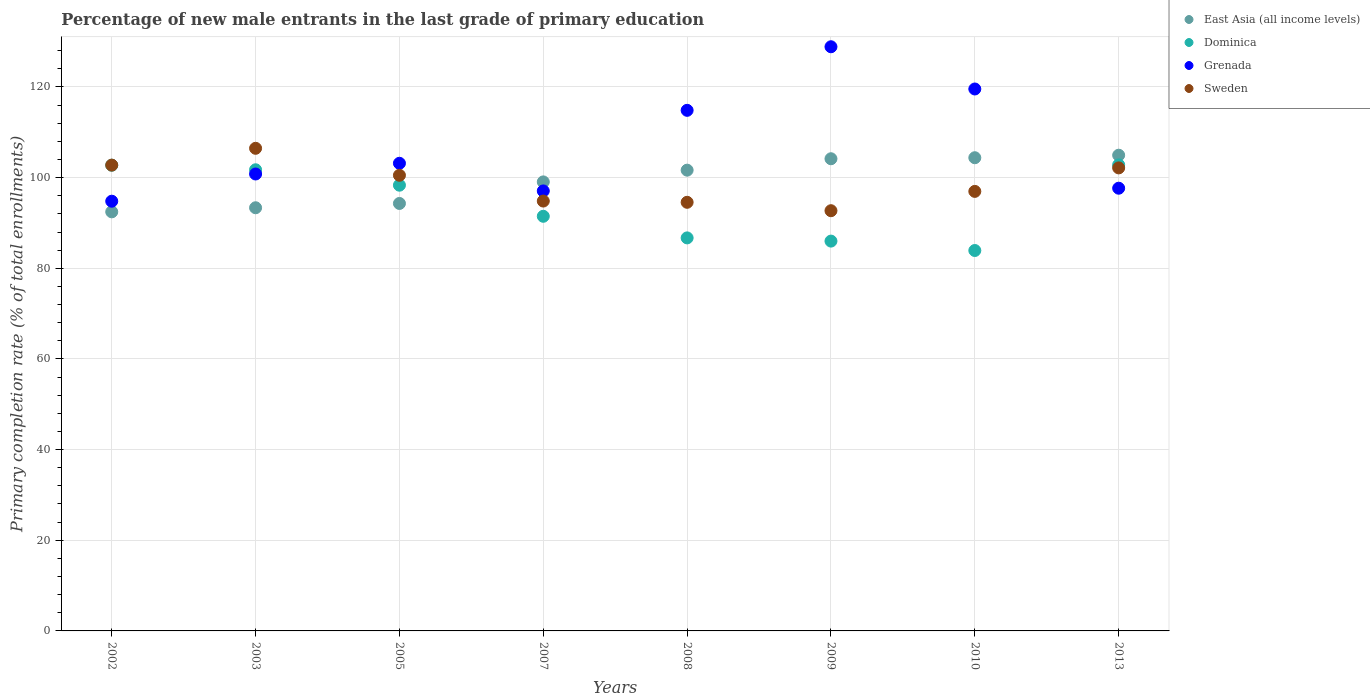How many different coloured dotlines are there?
Give a very brief answer. 4. Is the number of dotlines equal to the number of legend labels?
Ensure brevity in your answer.  Yes. What is the percentage of new male entrants in East Asia (all income levels) in 2007?
Give a very brief answer. 99.06. Across all years, what is the maximum percentage of new male entrants in Dominica?
Your answer should be very brief. 102.82. Across all years, what is the minimum percentage of new male entrants in Grenada?
Ensure brevity in your answer.  94.8. In which year was the percentage of new male entrants in East Asia (all income levels) minimum?
Keep it short and to the point. 2002. What is the total percentage of new male entrants in East Asia (all income levels) in the graph?
Keep it short and to the point. 794.31. What is the difference between the percentage of new male entrants in Sweden in 2002 and that in 2003?
Give a very brief answer. -3.71. What is the difference between the percentage of new male entrants in East Asia (all income levels) in 2002 and the percentage of new male entrants in Sweden in 2009?
Your response must be concise. -0.25. What is the average percentage of new male entrants in East Asia (all income levels) per year?
Keep it short and to the point. 99.29. In the year 2005, what is the difference between the percentage of new male entrants in Sweden and percentage of new male entrants in Grenada?
Keep it short and to the point. -2.65. What is the ratio of the percentage of new male entrants in Sweden in 2002 to that in 2010?
Provide a succinct answer. 1.06. Is the percentage of new male entrants in Grenada in 2003 less than that in 2013?
Ensure brevity in your answer.  No. Is the difference between the percentage of new male entrants in Sweden in 2009 and 2010 greater than the difference between the percentage of new male entrants in Grenada in 2009 and 2010?
Your answer should be compact. No. What is the difference between the highest and the second highest percentage of new male entrants in Sweden?
Offer a terse response. 3.71. What is the difference between the highest and the lowest percentage of new male entrants in Dominica?
Give a very brief answer. 18.9. In how many years, is the percentage of new male entrants in Grenada greater than the average percentage of new male entrants in Grenada taken over all years?
Provide a succinct answer. 3. Is the sum of the percentage of new male entrants in Grenada in 2002 and 2003 greater than the maximum percentage of new male entrants in East Asia (all income levels) across all years?
Keep it short and to the point. Yes. Is it the case that in every year, the sum of the percentage of new male entrants in Dominica and percentage of new male entrants in Grenada  is greater than the percentage of new male entrants in East Asia (all income levels)?
Your response must be concise. Yes. Does the percentage of new male entrants in Grenada monotonically increase over the years?
Your response must be concise. No. Is the percentage of new male entrants in Dominica strictly greater than the percentage of new male entrants in East Asia (all income levels) over the years?
Give a very brief answer. No. Is the percentage of new male entrants in Dominica strictly less than the percentage of new male entrants in Grenada over the years?
Ensure brevity in your answer.  No. How many years are there in the graph?
Ensure brevity in your answer.  8. What is the difference between two consecutive major ticks on the Y-axis?
Provide a succinct answer. 20. Are the values on the major ticks of Y-axis written in scientific E-notation?
Offer a terse response. No. Does the graph contain any zero values?
Give a very brief answer. No. Where does the legend appear in the graph?
Offer a very short reply. Top right. How are the legend labels stacked?
Give a very brief answer. Vertical. What is the title of the graph?
Your response must be concise. Percentage of new male entrants in the last grade of primary education. What is the label or title of the Y-axis?
Offer a very short reply. Primary completion rate (% of total enrollments). What is the Primary completion rate (% of total enrollments) in East Asia (all income levels) in 2002?
Provide a short and direct response. 92.45. What is the Primary completion rate (% of total enrollments) in Dominica in 2002?
Give a very brief answer. 102.74. What is the Primary completion rate (% of total enrollments) in Grenada in 2002?
Make the answer very short. 94.8. What is the Primary completion rate (% of total enrollments) in Sweden in 2002?
Offer a terse response. 102.76. What is the Primary completion rate (% of total enrollments) in East Asia (all income levels) in 2003?
Your answer should be compact. 93.35. What is the Primary completion rate (% of total enrollments) in Dominica in 2003?
Make the answer very short. 101.73. What is the Primary completion rate (% of total enrollments) in Grenada in 2003?
Provide a succinct answer. 100.8. What is the Primary completion rate (% of total enrollments) of Sweden in 2003?
Keep it short and to the point. 106.47. What is the Primary completion rate (% of total enrollments) in East Asia (all income levels) in 2005?
Offer a terse response. 94.3. What is the Primary completion rate (% of total enrollments) in Dominica in 2005?
Your answer should be very brief. 98.33. What is the Primary completion rate (% of total enrollments) of Grenada in 2005?
Give a very brief answer. 103.17. What is the Primary completion rate (% of total enrollments) in Sweden in 2005?
Keep it short and to the point. 100.52. What is the Primary completion rate (% of total enrollments) of East Asia (all income levels) in 2007?
Your answer should be very brief. 99.06. What is the Primary completion rate (% of total enrollments) in Dominica in 2007?
Provide a succinct answer. 91.47. What is the Primary completion rate (% of total enrollments) of Grenada in 2007?
Keep it short and to the point. 97.07. What is the Primary completion rate (% of total enrollments) of Sweden in 2007?
Keep it short and to the point. 94.83. What is the Primary completion rate (% of total enrollments) in East Asia (all income levels) in 2008?
Keep it short and to the point. 101.65. What is the Primary completion rate (% of total enrollments) in Dominica in 2008?
Your answer should be compact. 86.71. What is the Primary completion rate (% of total enrollments) of Grenada in 2008?
Provide a short and direct response. 114.85. What is the Primary completion rate (% of total enrollments) of Sweden in 2008?
Give a very brief answer. 94.56. What is the Primary completion rate (% of total enrollments) of East Asia (all income levels) in 2009?
Provide a short and direct response. 104.16. What is the Primary completion rate (% of total enrollments) of Dominica in 2009?
Your answer should be very brief. 86. What is the Primary completion rate (% of total enrollments) in Grenada in 2009?
Make the answer very short. 128.87. What is the Primary completion rate (% of total enrollments) in Sweden in 2009?
Your response must be concise. 92.7. What is the Primary completion rate (% of total enrollments) in East Asia (all income levels) in 2010?
Offer a very short reply. 104.39. What is the Primary completion rate (% of total enrollments) of Dominica in 2010?
Provide a short and direct response. 83.92. What is the Primary completion rate (% of total enrollments) in Grenada in 2010?
Offer a terse response. 119.55. What is the Primary completion rate (% of total enrollments) of Sweden in 2010?
Provide a succinct answer. 96.96. What is the Primary completion rate (% of total enrollments) in East Asia (all income levels) in 2013?
Offer a very short reply. 104.95. What is the Primary completion rate (% of total enrollments) in Dominica in 2013?
Offer a terse response. 102.82. What is the Primary completion rate (% of total enrollments) of Grenada in 2013?
Keep it short and to the point. 97.66. What is the Primary completion rate (% of total enrollments) in Sweden in 2013?
Make the answer very short. 102.15. Across all years, what is the maximum Primary completion rate (% of total enrollments) of East Asia (all income levels)?
Give a very brief answer. 104.95. Across all years, what is the maximum Primary completion rate (% of total enrollments) of Dominica?
Keep it short and to the point. 102.82. Across all years, what is the maximum Primary completion rate (% of total enrollments) of Grenada?
Your answer should be very brief. 128.87. Across all years, what is the maximum Primary completion rate (% of total enrollments) in Sweden?
Your answer should be compact. 106.47. Across all years, what is the minimum Primary completion rate (% of total enrollments) in East Asia (all income levels)?
Offer a very short reply. 92.45. Across all years, what is the minimum Primary completion rate (% of total enrollments) of Dominica?
Give a very brief answer. 83.92. Across all years, what is the minimum Primary completion rate (% of total enrollments) of Grenada?
Your answer should be compact. 94.8. Across all years, what is the minimum Primary completion rate (% of total enrollments) of Sweden?
Your answer should be compact. 92.7. What is the total Primary completion rate (% of total enrollments) in East Asia (all income levels) in the graph?
Make the answer very short. 794.31. What is the total Primary completion rate (% of total enrollments) in Dominica in the graph?
Provide a short and direct response. 753.72. What is the total Primary completion rate (% of total enrollments) in Grenada in the graph?
Ensure brevity in your answer.  856.77. What is the total Primary completion rate (% of total enrollments) of Sweden in the graph?
Offer a terse response. 790.94. What is the difference between the Primary completion rate (% of total enrollments) of East Asia (all income levels) in 2002 and that in 2003?
Your response must be concise. -0.9. What is the difference between the Primary completion rate (% of total enrollments) of Dominica in 2002 and that in 2003?
Your answer should be very brief. 1.01. What is the difference between the Primary completion rate (% of total enrollments) of Grenada in 2002 and that in 2003?
Make the answer very short. -6. What is the difference between the Primary completion rate (% of total enrollments) of Sweden in 2002 and that in 2003?
Offer a very short reply. -3.71. What is the difference between the Primary completion rate (% of total enrollments) of East Asia (all income levels) in 2002 and that in 2005?
Ensure brevity in your answer.  -1.85. What is the difference between the Primary completion rate (% of total enrollments) of Dominica in 2002 and that in 2005?
Offer a very short reply. 4.41. What is the difference between the Primary completion rate (% of total enrollments) in Grenada in 2002 and that in 2005?
Give a very brief answer. -8.37. What is the difference between the Primary completion rate (% of total enrollments) in Sweden in 2002 and that in 2005?
Offer a terse response. 2.24. What is the difference between the Primary completion rate (% of total enrollments) in East Asia (all income levels) in 2002 and that in 2007?
Ensure brevity in your answer.  -6.6. What is the difference between the Primary completion rate (% of total enrollments) of Dominica in 2002 and that in 2007?
Your answer should be very brief. 11.27. What is the difference between the Primary completion rate (% of total enrollments) in Grenada in 2002 and that in 2007?
Make the answer very short. -2.27. What is the difference between the Primary completion rate (% of total enrollments) of Sweden in 2002 and that in 2007?
Provide a short and direct response. 7.93. What is the difference between the Primary completion rate (% of total enrollments) in East Asia (all income levels) in 2002 and that in 2008?
Offer a very short reply. -9.19. What is the difference between the Primary completion rate (% of total enrollments) of Dominica in 2002 and that in 2008?
Offer a very short reply. 16.03. What is the difference between the Primary completion rate (% of total enrollments) in Grenada in 2002 and that in 2008?
Your answer should be very brief. -20.05. What is the difference between the Primary completion rate (% of total enrollments) in Sweden in 2002 and that in 2008?
Offer a terse response. 8.2. What is the difference between the Primary completion rate (% of total enrollments) in East Asia (all income levels) in 2002 and that in 2009?
Keep it short and to the point. -11.71. What is the difference between the Primary completion rate (% of total enrollments) of Dominica in 2002 and that in 2009?
Make the answer very short. 16.74. What is the difference between the Primary completion rate (% of total enrollments) of Grenada in 2002 and that in 2009?
Ensure brevity in your answer.  -34.07. What is the difference between the Primary completion rate (% of total enrollments) of Sweden in 2002 and that in 2009?
Make the answer very short. 10.06. What is the difference between the Primary completion rate (% of total enrollments) of East Asia (all income levels) in 2002 and that in 2010?
Give a very brief answer. -11.94. What is the difference between the Primary completion rate (% of total enrollments) in Dominica in 2002 and that in 2010?
Provide a succinct answer. 18.82. What is the difference between the Primary completion rate (% of total enrollments) in Grenada in 2002 and that in 2010?
Provide a short and direct response. -24.76. What is the difference between the Primary completion rate (% of total enrollments) in Sweden in 2002 and that in 2010?
Your answer should be very brief. 5.8. What is the difference between the Primary completion rate (% of total enrollments) of East Asia (all income levels) in 2002 and that in 2013?
Give a very brief answer. -12.49. What is the difference between the Primary completion rate (% of total enrollments) of Dominica in 2002 and that in 2013?
Give a very brief answer. -0.08. What is the difference between the Primary completion rate (% of total enrollments) of Grenada in 2002 and that in 2013?
Your answer should be compact. -2.87. What is the difference between the Primary completion rate (% of total enrollments) in Sweden in 2002 and that in 2013?
Your response must be concise. 0.61. What is the difference between the Primary completion rate (% of total enrollments) of East Asia (all income levels) in 2003 and that in 2005?
Your answer should be very brief. -0.95. What is the difference between the Primary completion rate (% of total enrollments) of Dominica in 2003 and that in 2005?
Your response must be concise. 3.4. What is the difference between the Primary completion rate (% of total enrollments) of Grenada in 2003 and that in 2005?
Offer a very short reply. -2.37. What is the difference between the Primary completion rate (% of total enrollments) in Sweden in 2003 and that in 2005?
Give a very brief answer. 5.95. What is the difference between the Primary completion rate (% of total enrollments) of East Asia (all income levels) in 2003 and that in 2007?
Offer a very short reply. -5.71. What is the difference between the Primary completion rate (% of total enrollments) in Dominica in 2003 and that in 2007?
Ensure brevity in your answer.  10.26. What is the difference between the Primary completion rate (% of total enrollments) of Grenada in 2003 and that in 2007?
Keep it short and to the point. 3.73. What is the difference between the Primary completion rate (% of total enrollments) in Sweden in 2003 and that in 2007?
Make the answer very short. 11.64. What is the difference between the Primary completion rate (% of total enrollments) of East Asia (all income levels) in 2003 and that in 2008?
Give a very brief answer. -8.29. What is the difference between the Primary completion rate (% of total enrollments) of Dominica in 2003 and that in 2008?
Your response must be concise. 15.03. What is the difference between the Primary completion rate (% of total enrollments) of Grenada in 2003 and that in 2008?
Provide a succinct answer. -14.05. What is the difference between the Primary completion rate (% of total enrollments) in Sweden in 2003 and that in 2008?
Provide a succinct answer. 11.91. What is the difference between the Primary completion rate (% of total enrollments) in East Asia (all income levels) in 2003 and that in 2009?
Provide a succinct answer. -10.81. What is the difference between the Primary completion rate (% of total enrollments) in Dominica in 2003 and that in 2009?
Offer a very short reply. 15.74. What is the difference between the Primary completion rate (% of total enrollments) of Grenada in 2003 and that in 2009?
Provide a short and direct response. -28.07. What is the difference between the Primary completion rate (% of total enrollments) of Sweden in 2003 and that in 2009?
Offer a very short reply. 13.77. What is the difference between the Primary completion rate (% of total enrollments) of East Asia (all income levels) in 2003 and that in 2010?
Provide a short and direct response. -11.04. What is the difference between the Primary completion rate (% of total enrollments) in Dominica in 2003 and that in 2010?
Offer a very short reply. 17.81. What is the difference between the Primary completion rate (% of total enrollments) of Grenada in 2003 and that in 2010?
Your answer should be very brief. -18.75. What is the difference between the Primary completion rate (% of total enrollments) in Sweden in 2003 and that in 2010?
Provide a short and direct response. 9.51. What is the difference between the Primary completion rate (% of total enrollments) of East Asia (all income levels) in 2003 and that in 2013?
Keep it short and to the point. -11.59. What is the difference between the Primary completion rate (% of total enrollments) of Dominica in 2003 and that in 2013?
Your answer should be compact. -1.09. What is the difference between the Primary completion rate (% of total enrollments) in Grenada in 2003 and that in 2013?
Your answer should be compact. 3.14. What is the difference between the Primary completion rate (% of total enrollments) of Sweden in 2003 and that in 2013?
Provide a short and direct response. 4.32. What is the difference between the Primary completion rate (% of total enrollments) of East Asia (all income levels) in 2005 and that in 2007?
Offer a terse response. -4.76. What is the difference between the Primary completion rate (% of total enrollments) in Dominica in 2005 and that in 2007?
Make the answer very short. 6.86. What is the difference between the Primary completion rate (% of total enrollments) of Grenada in 2005 and that in 2007?
Your response must be concise. 6.1. What is the difference between the Primary completion rate (% of total enrollments) in Sweden in 2005 and that in 2007?
Make the answer very short. 5.69. What is the difference between the Primary completion rate (% of total enrollments) of East Asia (all income levels) in 2005 and that in 2008?
Make the answer very short. -7.34. What is the difference between the Primary completion rate (% of total enrollments) in Dominica in 2005 and that in 2008?
Offer a terse response. 11.63. What is the difference between the Primary completion rate (% of total enrollments) in Grenada in 2005 and that in 2008?
Your answer should be very brief. -11.68. What is the difference between the Primary completion rate (% of total enrollments) of Sweden in 2005 and that in 2008?
Make the answer very short. 5.96. What is the difference between the Primary completion rate (% of total enrollments) in East Asia (all income levels) in 2005 and that in 2009?
Offer a terse response. -9.86. What is the difference between the Primary completion rate (% of total enrollments) in Dominica in 2005 and that in 2009?
Offer a terse response. 12.33. What is the difference between the Primary completion rate (% of total enrollments) in Grenada in 2005 and that in 2009?
Offer a very short reply. -25.7. What is the difference between the Primary completion rate (% of total enrollments) of Sweden in 2005 and that in 2009?
Offer a very short reply. 7.82. What is the difference between the Primary completion rate (% of total enrollments) of East Asia (all income levels) in 2005 and that in 2010?
Your response must be concise. -10.09. What is the difference between the Primary completion rate (% of total enrollments) of Dominica in 2005 and that in 2010?
Your answer should be very brief. 14.41. What is the difference between the Primary completion rate (% of total enrollments) in Grenada in 2005 and that in 2010?
Your response must be concise. -16.39. What is the difference between the Primary completion rate (% of total enrollments) of Sweden in 2005 and that in 2010?
Give a very brief answer. 3.55. What is the difference between the Primary completion rate (% of total enrollments) of East Asia (all income levels) in 2005 and that in 2013?
Your answer should be compact. -10.64. What is the difference between the Primary completion rate (% of total enrollments) of Dominica in 2005 and that in 2013?
Provide a succinct answer. -4.49. What is the difference between the Primary completion rate (% of total enrollments) in Grenada in 2005 and that in 2013?
Provide a succinct answer. 5.5. What is the difference between the Primary completion rate (% of total enrollments) in Sweden in 2005 and that in 2013?
Make the answer very short. -1.63. What is the difference between the Primary completion rate (% of total enrollments) in East Asia (all income levels) in 2007 and that in 2008?
Provide a succinct answer. -2.59. What is the difference between the Primary completion rate (% of total enrollments) of Dominica in 2007 and that in 2008?
Offer a terse response. 4.77. What is the difference between the Primary completion rate (% of total enrollments) of Grenada in 2007 and that in 2008?
Provide a short and direct response. -17.78. What is the difference between the Primary completion rate (% of total enrollments) of Sweden in 2007 and that in 2008?
Your answer should be very brief. 0.27. What is the difference between the Primary completion rate (% of total enrollments) of East Asia (all income levels) in 2007 and that in 2009?
Provide a succinct answer. -5.11. What is the difference between the Primary completion rate (% of total enrollments) of Dominica in 2007 and that in 2009?
Your answer should be compact. 5.47. What is the difference between the Primary completion rate (% of total enrollments) in Grenada in 2007 and that in 2009?
Ensure brevity in your answer.  -31.8. What is the difference between the Primary completion rate (% of total enrollments) in Sweden in 2007 and that in 2009?
Offer a terse response. 2.13. What is the difference between the Primary completion rate (% of total enrollments) in East Asia (all income levels) in 2007 and that in 2010?
Ensure brevity in your answer.  -5.33. What is the difference between the Primary completion rate (% of total enrollments) of Dominica in 2007 and that in 2010?
Your answer should be very brief. 7.55. What is the difference between the Primary completion rate (% of total enrollments) in Grenada in 2007 and that in 2010?
Keep it short and to the point. -22.49. What is the difference between the Primary completion rate (% of total enrollments) in Sweden in 2007 and that in 2010?
Provide a succinct answer. -2.13. What is the difference between the Primary completion rate (% of total enrollments) of East Asia (all income levels) in 2007 and that in 2013?
Offer a terse response. -5.89. What is the difference between the Primary completion rate (% of total enrollments) in Dominica in 2007 and that in 2013?
Your answer should be compact. -11.35. What is the difference between the Primary completion rate (% of total enrollments) in Grenada in 2007 and that in 2013?
Keep it short and to the point. -0.6. What is the difference between the Primary completion rate (% of total enrollments) of Sweden in 2007 and that in 2013?
Offer a terse response. -7.32. What is the difference between the Primary completion rate (% of total enrollments) in East Asia (all income levels) in 2008 and that in 2009?
Your answer should be very brief. -2.52. What is the difference between the Primary completion rate (% of total enrollments) of Dominica in 2008 and that in 2009?
Your response must be concise. 0.71. What is the difference between the Primary completion rate (% of total enrollments) of Grenada in 2008 and that in 2009?
Provide a succinct answer. -14.02. What is the difference between the Primary completion rate (% of total enrollments) of Sweden in 2008 and that in 2009?
Keep it short and to the point. 1.85. What is the difference between the Primary completion rate (% of total enrollments) in East Asia (all income levels) in 2008 and that in 2010?
Keep it short and to the point. -2.75. What is the difference between the Primary completion rate (% of total enrollments) in Dominica in 2008 and that in 2010?
Your answer should be compact. 2.78. What is the difference between the Primary completion rate (% of total enrollments) of Grenada in 2008 and that in 2010?
Provide a succinct answer. -4.71. What is the difference between the Primary completion rate (% of total enrollments) in Sweden in 2008 and that in 2010?
Give a very brief answer. -2.41. What is the difference between the Primary completion rate (% of total enrollments) in East Asia (all income levels) in 2008 and that in 2013?
Provide a succinct answer. -3.3. What is the difference between the Primary completion rate (% of total enrollments) in Dominica in 2008 and that in 2013?
Provide a short and direct response. -16.11. What is the difference between the Primary completion rate (% of total enrollments) of Grenada in 2008 and that in 2013?
Offer a terse response. 17.18. What is the difference between the Primary completion rate (% of total enrollments) in Sweden in 2008 and that in 2013?
Keep it short and to the point. -7.59. What is the difference between the Primary completion rate (% of total enrollments) of East Asia (all income levels) in 2009 and that in 2010?
Provide a short and direct response. -0.23. What is the difference between the Primary completion rate (% of total enrollments) of Dominica in 2009 and that in 2010?
Your answer should be very brief. 2.07. What is the difference between the Primary completion rate (% of total enrollments) in Grenada in 2009 and that in 2010?
Your answer should be compact. 9.32. What is the difference between the Primary completion rate (% of total enrollments) of Sweden in 2009 and that in 2010?
Your response must be concise. -4.26. What is the difference between the Primary completion rate (% of total enrollments) of East Asia (all income levels) in 2009 and that in 2013?
Provide a short and direct response. -0.78. What is the difference between the Primary completion rate (% of total enrollments) in Dominica in 2009 and that in 2013?
Your response must be concise. -16.82. What is the difference between the Primary completion rate (% of total enrollments) in Grenada in 2009 and that in 2013?
Offer a terse response. 31.21. What is the difference between the Primary completion rate (% of total enrollments) in Sweden in 2009 and that in 2013?
Your answer should be very brief. -9.44. What is the difference between the Primary completion rate (% of total enrollments) of East Asia (all income levels) in 2010 and that in 2013?
Your response must be concise. -0.55. What is the difference between the Primary completion rate (% of total enrollments) of Dominica in 2010 and that in 2013?
Offer a terse response. -18.9. What is the difference between the Primary completion rate (% of total enrollments) in Grenada in 2010 and that in 2013?
Make the answer very short. 21.89. What is the difference between the Primary completion rate (% of total enrollments) in Sweden in 2010 and that in 2013?
Provide a short and direct response. -5.18. What is the difference between the Primary completion rate (% of total enrollments) of East Asia (all income levels) in 2002 and the Primary completion rate (% of total enrollments) of Dominica in 2003?
Your answer should be compact. -9.28. What is the difference between the Primary completion rate (% of total enrollments) of East Asia (all income levels) in 2002 and the Primary completion rate (% of total enrollments) of Grenada in 2003?
Your answer should be compact. -8.35. What is the difference between the Primary completion rate (% of total enrollments) of East Asia (all income levels) in 2002 and the Primary completion rate (% of total enrollments) of Sweden in 2003?
Provide a short and direct response. -14.02. What is the difference between the Primary completion rate (% of total enrollments) in Dominica in 2002 and the Primary completion rate (% of total enrollments) in Grenada in 2003?
Provide a short and direct response. 1.94. What is the difference between the Primary completion rate (% of total enrollments) in Dominica in 2002 and the Primary completion rate (% of total enrollments) in Sweden in 2003?
Your response must be concise. -3.73. What is the difference between the Primary completion rate (% of total enrollments) of Grenada in 2002 and the Primary completion rate (% of total enrollments) of Sweden in 2003?
Your answer should be compact. -11.67. What is the difference between the Primary completion rate (% of total enrollments) in East Asia (all income levels) in 2002 and the Primary completion rate (% of total enrollments) in Dominica in 2005?
Provide a succinct answer. -5.88. What is the difference between the Primary completion rate (% of total enrollments) of East Asia (all income levels) in 2002 and the Primary completion rate (% of total enrollments) of Grenada in 2005?
Offer a very short reply. -10.71. What is the difference between the Primary completion rate (% of total enrollments) in East Asia (all income levels) in 2002 and the Primary completion rate (% of total enrollments) in Sweden in 2005?
Give a very brief answer. -8.06. What is the difference between the Primary completion rate (% of total enrollments) of Dominica in 2002 and the Primary completion rate (% of total enrollments) of Grenada in 2005?
Your answer should be very brief. -0.43. What is the difference between the Primary completion rate (% of total enrollments) in Dominica in 2002 and the Primary completion rate (% of total enrollments) in Sweden in 2005?
Provide a succinct answer. 2.22. What is the difference between the Primary completion rate (% of total enrollments) in Grenada in 2002 and the Primary completion rate (% of total enrollments) in Sweden in 2005?
Your response must be concise. -5.72. What is the difference between the Primary completion rate (% of total enrollments) of East Asia (all income levels) in 2002 and the Primary completion rate (% of total enrollments) of Dominica in 2007?
Offer a terse response. 0.98. What is the difference between the Primary completion rate (% of total enrollments) in East Asia (all income levels) in 2002 and the Primary completion rate (% of total enrollments) in Grenada in 2007?
Keep it short and to the point. -4.61. What is the difference between the Primary completion rate (% of total enrollments) of East Asia (all income levels) in 2002 and the Primary completion rate (% of total enrollments) of Sweden in 2007?
Your answer should be very brief. -2.38. What is the difference between the Primary completion rate (% of total enrollments) in Dominica in 2002 and the Primary completion rate (% of total enrollments) in Grenada in 2007?
Provide a short and direct response. 5.67. What is the difference between the Primary completion rate (% of total enrollments) in Dominica in 2002 and the Primary completion rate (% of total enrollments) in Sweden in 2007?
Make the answer very short. 7.91. What is the difference between the Primary completion rate (% of total enrollments) in Grenada in 2002 and the Primary completion rate (% of total enrollments) in Sweden in 2007?
Keep it short and to the point. -0.03. What is the difference between the Primary completion rate (% of total enrollments) in East Asia (all income levels) in 2002 and the Primary completion rate (% of total enrollments) in Dominica in 2008?
Your answer should be compact. 5.75. What is the difference between the Primary completion rate (% of total enrollments) in East Asia (all income levels) in 2002 and the Primary completion rate (% of total enrollments) in Grenada in 2008?
Offer a terse response. -22.39. What is the difference between the Primary completion rate (% of total enrollments) of East Asia (all income levels) in 2002 and the Primary completion rate (% of total enrollments) of Sweden in 2008?
Make the answer very short. -2.1. What is the difference between the Primary completion rate (% of total enrollments) in Dominica in 2002 and the Primary completion rate (% of total enrollments) in Grenada in 2008?
Give a very brief answer. -12.11. What is the difference between the Primary completion rate (% of total enrollments) of Dominica in 2002 and the Primary completion rate (% of total enrollments) of Sweden in 2008?
Provide a short and direct response. 8.18. What is the difference between the Primary completion rate (% of total enrollments) in Grenada in 2002 and the Primary completion rate (% of total enrollments) in Sweden in 2008?
Give a very brief answer. 0.24. What is the difference between the Primary completion rate (% of total enrollments) in East Asia (all income levels) in 2002 and the Primary completion rate (% of total enrollments) in Dominica in 2009?
Offer a terse response. 6.46. What is the difference between the Primary completion rate (% of total enrollments) in East Asia (all income levels) in 2002 and the Primary completion rate (% of total enrollments) in Grenada in 2009?
Offer a very short reply. -36.42. What is the difference between the Primary completion rate (% of total enrollments) in East Asia (all income levels) in 2002 and the Primary completion rate (% of total enrollments) in Sweden in 2009?
Your answer should be very brief. -0.25. What is the difference between the Primary completion rate (% of total enrollments) in Dominica in 2002 and the Primary completion rate (% of total enrollments) in Grenada in 2009?
Provide a short and direct response. -26.13. What is the difference between the Primary completion rate (% of total enrollments) of Dominica in 2002 and the Primary completion rate (% of total enrollments) of Sweden in 2009?
Provide a short and direct response. 10.04. What is the difference between the Primary completion rate (% of total enrollments) in Grenada in 2002 and the Primary completion rate (% of total enrollments) in Sweden in 2009?
Your response must be concise. 2.1. What is the difference between the Primary completion rate (% of total enrollments) of East Asia (all income levels) in 2002 and the Primary completion rate (% of total enrollments) of Dominica in 2010?
Offer a very short reply. 8.53. What is the difference between the Primary completion rate (% of total enrollments) of East Asia (all income levels) in 2002 and the Primary completion rate (% of total enrollments) of Grenada in 2010?
Provide a short and direct response. -27.1. What is the difference between the Primary completion rate (% of total enrollments) in East Asia (all income levels) in 2002 and the Primary completion rate (% of total enrollments) in Sweden in 2010?
Your answer should be very brief. -4.51. What is the difference between the Primary completion rate (% of total enrollments) in Dominica in 2002 and the Primary completion rate (% of total enrollments) in Grenada in 2010?
Make the answer very short. -16.82. What is the difference between the Primary completion rate (% of total enrollments) of Dominica in 2002 and the Primary completion rate (% of total enrollments) of Sweden in 2010?
Give a very brief answer. 5.78. What is the difference between the Primary completion rate (% of total enrollments) of Grenada in 2002 and the Primary completion rate (% of total enrollments) of Sweden in 2010?
Offer a terse response. -2.17. What is the difference between the Primary completion rate (% of total enrollments) of East Asia (all income levels) in 2002 and the Primary completion rate (% of total enrollments) of Dominica in 2013?
Your answer should be very brief. -10.37. What is the difference between the Primary completion rate (% of total enrollments) of East Asia (all income levels) in 2002 and the Primary completion rate (% of total enrollments) of Grenada in 2013?
Your answer should be compact. -5.21. What is the difference between the Primary completion rate (% of total enrollments) of East Asia (all income levels) in 2002 and the Primary completion rate (% of total enrollments) of Sweden in 2013?
Offer a terse response. -9.69. What is the difference between the Primary completion rate (% of total enrollments) in Dominica in 2002 and the Primary completion rate (% of total enrollments) in Grenada in 2013?
Your response must be concise. 5.08. What is the difference between the Primary completion rate (% of total enrollments) of Dominica in 2002 and the Primary completion rate (% of total enrollments) of Sweden in 2013?
Offer a terse response. 0.59. What is the difference between the Primary completion rate (% of total enrollments) of Grenada in 2002 and the Primary completion rate (% of total enrollments) of Sweden in 2013?
Ensure brevity in your answer.  -7.35. What is the difference between the Primary completion rate (% of total enrollments) in East Asia (all income levels) in 2003 and the Primary completion rate (% of total enrollments) in Dominica in 2005?
Ensure brevity in your answer.  -4.98. What is the difference between the Primary completion rate (% of total enrollments) in East Asia (all income levels) in 2003 and the Primary completion rate (% of total enrollments) in Grenada in 2005?
Offer a terse response. -9.81. What is the difference between the Primary completion rate (% of total enrollments) of East Asia (all income levels) in 2003 and the Primary completion rate (% of total enrollments) of Sweden in 2005?
Provide a short and direct response. -7.17. What is the difference between the Primary completion rate (% of total enrollments) in Dominica in 2003 and the Primary completion rate (% of total enrollments) in Grenada in 2005?
Offer a very short reply. -1.43. What is the difference between the Primary completion rate (% of total enrollments) in Dominica in 2003 and the Primary completion rate (% of total enrollments) in Sweden in 2005?
Give a very brief answer. 1.22. What is the difference between the Primary completion rate (% of total enrollments) of Grenada in 2003 and the Primary completion rate (% of total enrollments) of Sweden in 2005?
Give a very brief answer. 0.28. What is the difference between the Primary completion rate (% of total enrollments) of East Asia (all income levels) in 2003 and the Primary completion rate (% of total enrollments) of Dominica in 2007?
Make the answer very short. 1.88. What is the difference between the Primary completion rate (% of total enrollments) of East Asia (all income levels) in 2003 and the Primary completion rate (% of total enrollments) of Grenada in 2007?
Your answer should be very brief. -3.71. What is the difference between the Primary completion rate (% of total enrollments) of East Asia (all income levels) in 2003 and the Primary completion rate (% of total enrollments) of Sweden in 2007?
Give a very brief answer. -1.48. What is the difference between the Primary completion rate (% of total enrollments) in Dominica in 2003 and the Primary completion rate (% of total enrollments) in Grenada in 2007?
Your answer should be very brief. 4.67. What is the difference between the Primary completion rate (% of total enrollments) of Dominica in 2003 and the Primary completion rate (% of total enrollments) of Sweden in 2007?
Your response must be concise. 6.9. What is the difference between the Primary completion rate (% of total enrollments) of Grenada in 2003 and the Primary completion rate (% of total enrollments) of Sweden in 2007?
Ensure brevity in your answer.  5.97. What is the difference between the Primary completion rate (% of total enrollments) in East Asia (all income levels) in 2003 and the Primary completion rate (% of total enrollments) in Dominica in 2008?
Ensure brevity in your answer.  6.65. What is the difference between the Primary completion rate (% of total enrollments) in East Asia (all income levels) in 2003 and the Primary completion rate (% of total enrollments) in Grenada in 2008?
Provide a short and direct response. -21.49. What is the difference between the Primary completion rate (% of total enrollments) in East Asia (all income levels) in 2003 and the Primary completion rate (% of total enrollments) in Sweden in 2008?
Provide a short and direct response. -1.2. What is the difference between the Primary completion rate (% of total enrollments) of Dominica in 2003 and the Primary completion rate (% of total enrollments) of Grenada in 2008?
Offer a terse response. -13.11. What is the difference between the Primary completion rate (% of total enrollments) in Dominica in 2003 and the Primary completion rate (% of total enrollments) in Sweden in 2008?
Make the answer very short. 7.18. What is the difference between the Primary completion rate (% of total enrollments) in Grenada in 2003 and the Primary completion rate (% of total enrollments) in Sweden in 2008?
Provide a short and direct response. 6.24. What is the difference between the Primary completion rate (% of total enrollments) in East Asia (all income levels) in 2003 and the Primary completion rate (% of total enrollments) in Dominica in 2009?
Keep it short and to the point. 7.36. What is the difference between the Primary completion rate (% of total enrollments) of East Asia (all income levels) in 2003 and the Primary completion rate (% of total enrollments) of Grenada in 2009?
Your response must be concise. -35.52. What is the difference between the Primary completion rate (% of total enrollments) of East Asia (all income levels) in 2003 and the Primary completion rate (% of total enrollments) of Sweden in 2009?
Provide a short and direct response. 0.65. What is the difference between the Primary completion rate (% of total enrollments) of Dominica in 2003 and the Primary completion rate (% of total enrollments) of Grenada in 2009?
Offer a terse response. -27.14. What is the difference between the Primary completion rate (% of total enrollments) of Dominica in 2003 and the Primary completion rate (% of total enrollments) of Sweden in 2009?
Offer a very short reply. 9.03. What is the difference between the Primary completion rate (% of total enrollments) in Grenada in 2003 and the Primary completion rate (% of total enrollments) in Sweden in 2009?
Offer a terse response. 8.1. What is the difference between the Primary completion rate (% of total enrollments) in East Asia (all income levels) in 2003 and the Primary completion rate (% of total enrollments) in Dominica in 2010?
Provide a short and direct response. 9.43. What is the difference between the Primary completion rate (% of total enrollments) of East Asia (all income levels) in 2003 and the Primary completion rate (% of total enrollments) of Grenada in 2010?
Provide a succinct answer. -26.2. What is the difference between the Primary completion rate (% of total enrollments) in East Asia (all income levels) in 2003 and the Primary completion rate (% of total enrollments) in Sweden in 2010?
Give a very brief answer. -3.61. What is the difference between the Primary completion rate (% of total enrollments) of Dominica in 2003 and the Primary completion rate (% of total enrollments) of Grenada in 2010?
Offer a terse response. -17.82. What is the difference between the Primary completion rate (% of total enrollments) of Dominica in 2003 and the Primary completion rate (% of total enrollments) of Sweden in 2010?
Offer a terse response. 4.77. What is the difference between the Primary completion rate (% of total enrollments) in Grenada in 2003 and the Primary completion rate (% of total enrollments) in Sweden in 2010?
Your answer should be very brief. 3.84. What is the difference between the Primary completion rate (% of total enrollments) in East Asia (all income levels) in 2003 and the Primary completion rate (% of total enrollments) in Dominica in 2013?
Keep it short and to the point. -9.47. What is the difference between the Primary completion rate (% of total enrollments) of East Asia (all income levels) in 2003 and the Primary completion rate (% of total enrollments) of Grenada in 2013?
Ensure brevity in your answer.  -4.31. What is the difference between the Primary completion rate (% of total enrollments) of East Asia (all income levels) in 2003 and the Primary completion rate (% of total enrollments) of Sweden in 2013?
Make the answer very short. -8.79. What is the difference between the Primary completion rate (% of total enrollments) in Dominica in 2003 and the Primary completion rate (% of total enrollments) in Grenada in 2013?
Offer a very short reply. 4.07. What is the difference between the Primary completion rate (% of total enrollments) of Dominica in 2003 and the Primary completion rate (% of total enrollments) of Sweden in 2013?
Provide a short and direct response. -0.41. What is the difference between the Primary completion rate (% of total enrollments) in Grenada in 2003 and the Primary completion rate (% of total enrollments) in Sweden in 2013?
Your response must be concise. -1.35. What is the difference between the Primary completion rate (% of total enrollments) of East Asia (all income levels) in 2005 and the Primary completion rate (% of total enrollments) of Dominica in 2007?
Your response must be concise. 2.83. What is the difference between the Primary completion rate (% of total enrollments) of East Asia (all income levels) in 2005 and the Primary completion rate (% of total enrollments) of Grenada in 2007?
Your answer should be very brief. -2.77. What is the difference between the Primary completion rate (% of total enrollments) of East Asia (all income levels) in 2005 and the Primary completion rate (% of total enrollments) of Sweden in 2007?
Make the answer very short. -0.53. What is the difference between the Primary completion rate (% of total enrollments) of Dominica in 2005 and the Primary completion rate (% of total enrollments) of Grenada in 2007?
Keep it short and to the point. 1.26. What is the difference between the Primary completion rate (% of total enrollments) of Dominica in 2005 and the Primary completion rate (% of total enrollments) of Sweden in 2007?
Your answer should be compact. 3.5. What is the difference between the Primary completion rate (% of total enrollments) in Grenada in 2005 and the Primary completion rate (% of total enrollments) in Sweden in 2007?
Provide a succinct answer. 8.34. What is the difference between the Primary completion rate (% of total enrollments) in East Asia (all income levels) in 2005 and the Primary completion rate (% of total enrollments) in Dominica in 2008?
Offer a terse response. 7.6. What is the difference between the Primary completion rate (% of total enrollments) of East Asia (all income levels) in 2005 and the Primary completion rate (% of total enrollments) of Grenada in 2008?
Your answer should be very brief. -20.54. What is the difference between the Primary completion rate (% of total enrollments) in East Asia (all income levels) in 2005 and the Primary completion rate (% of total enrollments) in Sweden in 2008?
Ensure brevity in your answer.  -0.25. What is the difference between the Primary completion rate (% of total enrollments) of Dominica in 2005 and the Primary completion rate (% of total enrollments) of Grenada in 2008?
Ensure brevity in your answer.  -16.51. What is the difference between the Primary completion rate (% of total enrollments) of Dominica in 2005 and the Primary completion rate (% of total enrollments) of Sweden in 2008?
Offer a terse response. 3.77. What is the difference between the Primary completion rate (% of total enrollments) in Grenada in 2005 and the Primary completion rate (% of total enrollments) in Sweden in 2008?
Provide a succinct answer. 8.61. What is the difference between the Primary completion rate (% of total enrollments) of East Asia (all income levels) in 2005 and the Primary completion rate (% of total enrollments) of Dominica in 2009?
Offer a very short reply. 8.3. What is the difference between the Primary completion rate (% of total enrollments) of East Asia (all income levels) in 2005 and the Primary completion rate (% of total enrollments) of Grenada in 2009?
Your answer should be compact. -34.57. What is the difference between the Primary completion rate (% of total enrollments) of East Asia (all income levels) in 2005 and the Primary completion rate (% of total enrollments) of Sweden in 2009?
Give a very brief answer. 1.6. What is the difference between the Primary completion rate (% of total enrollments) in Dominica in 2005 and the Primary completion rate (% of total enrollments) in Grenada in 2009?
Your answer should be very brief. -30.54. What is the difference between the Primary completion rate (% of total enrollments) in Dominica in 2005 and the Primary completion rate (% of total enrollments) in Sweden in 2009?
Offer a very short reply. 5.63. What is the difference between the Primary completion rate (% of total enrollments) of Grenada in 2005 and the Primary completion rate (% of total enrollments) of Sweden in 2009?
Ensure brevity in your answer.  10.46. What is the difference between the Primary completion rate (% of total enrollments) in East Asia (all income levels) in 2005 and the Primary completion rate (% of total enrollments) in Dominica in 2010?
Provide a succinct answer. 10.38. What is the difference between the Primary completion rate (% of total enrollments) in East Asia (all income levels) in 2005 and the Primary completion rate (% of total enrollments) in Grenada in 2010?
Offer a very short reply. -25.25. What is the difference between the Primary completion rate (% of total enrollments) in East Asia (all income levels) in 2005 and the Primary completion rate (% of total enrollments) in Sweden in 2010?
Ensure brevity in your answer.  -2.66. What is the difference between the Primary completion rate (% of total enrollments) of Dominica in 2005 and the Primary completion rate (% of total enrollments) of Grenada in 2010?
Offer a very short reply. -21.22. What is the difference between the Primary completion rate (% of total enrollments) in Dominica in 2005 and the Primary completion rate (% of total enrollments) in Sweden in 2010?
Offer a very short reply. 1.37. What is the difference between the Primary completion rate (% of total enrollments) in Grenada in 2005 and the Primary completion rate (% of total enrollments) in Sweden in 2010?
Offer a very short reply. 6.2. What is the difference between the Primary completion rate (% of total enrollments) of East Asia (all income levels) in 2005 and the Primary completion rate (% of total enrollments) of Dominica in 2013?
Make the answer very short. -8.52. What is the difference between the Primary completion rate (% of total enrollments) of East Asia (all income levels) in 2005 and the Primary completion rate (% of total enrollments) of Grenada in 2013?
Provide a short and direct response. -3.36. What is the difference between the Primary completion rate (% of total enrollments) in East Asia (all income levels) in 2005 and the Primary completion rate (% of total enrollments) in Sweden in 2013?
Provide a succinct answer. -7.84. What is the difference between the Primary completion rate (% of total enrollments) in Dominica in 2005 and the Primary completion rate (% of total enrollments) in Grenada in 2013?
Offer a terse response. 0.67. What is the difference between the Primary completion rate (% of total enrollments) of Dominica in 2005 and the Primary completion rate (% of total enrollments) of Sweden in 2013?
Your response must be concise. -3.82. What is the difference between the Primary completion rate (% of total enrollments) in Grenada in 2005 and the Primary completion rate (% of total enrollments) in Sweden in 2013?
Your response must be concise. 1.02. What is the difference between the Primary completion rate (% of total enrollments) of East Asia (all income levels) in 2007 and the Primary completion rate (% of total enrollments) of Dominica in 2008?
Keep it short and to the point. 12.35. What is the difference between the Primary completion rate (% of total enrollments) in East Asia (all income levels) in 2007 and the Primary completion rate (% of total enrollments) in Grenada in 2008?
Ensure brevity in your answer.  -15.79. What is the difference between the Primary completion rate (% of total enrollments) in East Asia (all income levels) in 2007 and the Primary completion rate (% of total enrollments) in Sweden in 2008?
Make the answer very short. 4.5. What is the difference between the Primary completion rate (% of total enrollments) of Dominica in 2007 and the Primary completion rate (% of total enrollments) of Grenada in 2008?
Give a very brief answer. -23.37. What is the difference between the Primary completion rate (% of total enrollments) in Dominica in 2007 and the Primary completion rate (% of total enrollments) in Sweden in 2008?
Keep it short and to the point. -3.08. What is the difference between the Primary completion rate (% of total enrollments) of Grenada in 2007 and the Primary completion rate (% of total enrollments) of Sweden in 2008?
Ensure brevity in your answer.  2.51. What is the difference between the Primary completion rate (% of total enrollments) in East Asia (all income levels) in 2007 and the Primary completion rate (% of total enrollments) in Dominica in 2009?
Ensure brevity in your answer.  13.06. What is the difference between the Primary completion rate (% of total enrollments) in East Asia (all income levels) in 2007 and the Primary completion rate (% of total enrollments) in Grenada in 2009?
Your answer should be compact. -29.81. What is the difference between the Primary completion rate (% of total enrollments) of East Asia (all income levels) in 2007 and the Primary completion rate (% of total enrollments) of Sweden in 2009?
Your answer should be very brief. 6.36. What is the difference between the Primary completion rate (% of total enrollments) in Dominica in 2007 and the Primary completion rate (% of total enrollments) in Grenada in 2009?
Your answer should be very brief. -37.4. What is the difference between the Primary completion rate (% of total enrollments) of Dominica in 2007 and the Primary completion rate (% of total enrollments) of Sweden in 2009?
Your response must be concise. -1.23. What is the difference between the Primary completion rate (% of total enrollments) of Grenada in 2007 and the Primary completion rate (% of total enrollments) of Sweden in 2009?
Your response must be concise. 4.37. What is the difference between the Primary completion rate (% of total enrollments) in East Asia (all income levels) in 2007 and the Primary completion rate (% of total enrollments) in Dominica in 2010?
Your answer should be very brief. 15.14. What is the difference between the Primary completion rate (% of total enrollments) of East Asia (all income levels) in 2007 and the Primary completion rate (% of total enrollments) of Grenada in 2010?
Your answer should be compact. -20.5. What is the difference between the Primary completion rate (% of total enrollments) in East Asia (all income levels) in 2007 and the Primary completion rate (% of total enrollments) in Sweden in 2010?
Your answer should be compact. 2.09. What is the difference between the Primary completion rate (% of total enrollments) in Dominica in 2007 and the Primary completion rate (% of total enrollments) in Grenada in 2010?
Your answer should be compact. -28.08. What is the difference between the Primary completion rate (% of total enrollments) in Dominica in 2007 and the Primary completion rate (% of total enrollments) in Sweden in 2010?
Your answer should be compact. -5.49. What is the difference between the Primary completion rate (% of total enrollments) of Grenada in 2007 and the Primary completion rate (% of total enrollments) of Sweden in 2010?
Your answer should be very brief. 0.1. What is the difference between the Primary completion rate (% of total enrollments) of East Asia (all income levels) in 2007 and the Primary completion rate (% of total enrollments) of Dominica in 2013?
Your answer should be very brief. -3.76. What is the difference between the Primary completion rate (% of total enrollments) in East Asia (all income levels) in 2007 and the Primary completion rate (% of total enrollments) in Grenada in 2013?
Offer a very short reply. 1.39. What is the difference between the Primary completion rate (% of total enrollments) of East Asia (all income levels) in 2007 and the Primary completion rate (% of total enrollments) of Sweden in 2013?
Keep it short and to the point. -3.09. What is the difference between the Primary completion rate (% of total enrollments) of Dominica in 2007 and the Primary completion rate (% of total enrollments) of Grenada in 2013?
Keep it short and to the point. -6.19. What is the difference between the Primary completion rate (% of total enrollments) in Dominica in 2007 and the Primary completion rate (% of total enrollments) in Sweden in 2013?
Offer a terse response. -10.67. What is the difference between the Primary completion rate (% of total enrollments) in Grenada in 2007 and the Primary completion rate (% of total enrollments) in Sweden in 2013?
Make the answer very short. -5.08. What is the difference between the Primary completion rate (% of total enrollments) in East Asia (all income levels) in 2008 and the Primary completion rate (% of total enrollments) in Dominica in 2009?
Offer a very short reply. 15.65. What is the difference between the Primary completion rate (% of total enrollments) in East Asia (all income levels) in 2008 and the Primary completion rate (% of total enrollments) in Grenada in 2009?
Provide a short and direct response. -27.22. What is the difference between the Primary completion rate (% of total enrollments) of East Asia (all income levels) in 2008 and the Primary completion rate (% of total enrollments) of Sweden in 2009?
Keep it short and to the point. 8.94. What is the difference between the Primary completion rate (% of total enrollments) in Dominica in 2008 and the Primary completion rate (% of total enrollments) in Grenada in 2009?
Ensure brevity in your answer.  -42.16. What is the difference between the Primary completion rate (% of total enrollments) in Dominica in 2008 and the Primary completion rate (% of total enrollments) in Sweden in 2009?
Give a very brief answer. -6. What is the difference between the Primary completion rate (% of total enrollments) in Grenada in 2008 and the Primary completion rate (% of total enrollments) in Sweden in 2009?
Offer a terse response. 22.14. What is the difference between the Primary completion rate (% of total enrollments) in East Asia (all income levels) in 2008 and the Primary completion rate (% of total enrollments) in Dominica in 2010?
Ensure brevity in your answer.  17.72. What is the difference between the Primary completion rate (% of total enrollments) in East Asia (all income levels) in 2008 and the Primary completion rate (% of total enrollments) in Grenada in 2010?
Your answer should be very brief. -17.91. What is the difference between the Primary completion rate (% of total enrollments) in East Asia (all income levels) in 2008 and the Primary completion rate (% of total enrollments) in Sweden in 2010?
Ensure brevity in your answer.  4.68. What is the difference between the Primary completion rate (% of total enrollments) in Dominica in 2008 and the Primary completion rate (% of total enrollments) in Grenada in 2010?
Your answer should be very brief. -32.85. What is the difference between the Primary completion rate (% of total enrollments) of Dominica in 2008 and the Primary completion rate (% of total enrollments) of Sweden in 2010?
Offer a very short reply. -10.26. What is the difference between the Primary completion rate (% of total enrollments) of Grenada in 2008 and the Primary completion rate (% of total enrollments) of Sweden in 2010?
Keep it short and to the point. 17.88. What is the difference between the Primary completion rate (% of total enrollments) of East Asia (all income levels) in 2008 and the Primary completion rate (% of total enrollments) of Dominica in 2013?
Ensure brevity in your answer.  -1.17. What is the difference between the Primary completion rate (% of total enrollments) in East Asia (all income levels) in 2008 and the Primary completion rate (% of total enrollments) in Grenada in 2013?
Offer a very short reply. 3.98. What is the difference between the Primary completion rate (% of total enrollments) of East Asia (all income levels) in 2008 and the Primary completion rate (% of total enrollments) of Sweden in 2013?
Offer a very short reply. -0.5. What is the difference between the Primary completion rate (% of total enrollments) in Dominica in 2008 and the Primary completion rate (% of total enrollments) in Grenada in 2013?
Your response must be concise. -10.96. What is the difference between the Primary completion rate (% of total enrollments) of Dominica in 2008 and the Primary completion rate (% of total enrollments) of Sweden in 2013?
Make the answer very short. -15.44. What is the difference between the Primary completion rate (% of total enrollments) of Grenada in 2008 and the Primary completion rate (% of total enrollments) of Sweden in 2013?
Your answer should be very brief. 12.7. What is the difference between the Primary completion rate (% of total enrollments) of East Asia (all income levels) in 2009 and the Primary completion rate (% of total enrollments) of Dominica in 2010?
Your answer should be compact. 20.24. What is the difference between the Primary completion rate (% of total enrollments) of East Asia (all income levels) in 2009 and the Primary completion rate (% of total enrollments) of Grenada in 2010?
Keep it short and to the point. -15.39. What is the difference between the Primary completion rate (% of total enrollments) of East Asia (all income levels) in 2009 and the Primary completion rate (% of total enrollments) of Sweden in 2010?
Your answer should be compact. 7.2. What is the difference between the Primary completion rate (% of total enrollments) in Dominica in 2009 and the Primary completion rate (% of total enrollments) in Grenada in 2010?
Offer a terse response. -33.56. What is the difference between the Primary completion rate (% of total enrollments) in Dominica in 2009 and the Primary completion rate (% of total enrollments) in Sweden in 2010?
Your answer should be very brief. -10.97. What is the difference between the Primary completion rate (% of total enrollments) of Grenada in 2009 and the Primary completion rate (% of total enrollments) of Sweden in 2010?
Ensure brevity in your answer.  31.91. What is the difference between the Primary completion rate (% of total enrollments) in East Asia (all income levels) in 2009 and the Primary completion rate (% of total enrollments) in Dominica in 2013?
Your answer should be very brief. 1.35. What is the difference between the Primary completion rate (% of total enrollments) in East Asia (all income levels) in 2009 and the Primary completion rate (% of total enrollments) in Grenada in 2013?
Offer a very short reply. 6.5. What is the difference between the Primary completion rate (% of total enrollments) of East Asia (all income levels) in 2009 and the Primary completion rate (% of total enrollments) of Sweden in 2013?
Your answer should be very brief. 2.02. What is the difference between the Primary completion rate (% of total enrollments) in Dominica in 2009 and the Primary completion rate (% of total enrollments) in Grenada in 2013?
Give a very brief answer. -11.67. What is the difference between the Primary completion rate (% of total enrollments) in Dominica in 2009 and the Primary completion rate (% of total enrollments) in Sweden in 2013?
Provide a short and direct response. -16.15. What is the difference between the Primary completion rate (% of total enrollments) in Grenada in 2009 and the Primary completion rate (% of total enrollments) in Sweden in 2013?
Your answer should be very brief. 26.72. What is the difference between the Primary completion rate (% of total enrollments) in East Asia (all income levels) in 2010 and the Primary completion rate (% of total enrollments) in Dominica in 2013?
Ensure brevity in your answer.  1.57. What is the difference between the Primary completion rate (% of total enrollments) of East Asia (all income levels) in 2010 and the Primary completion rate (% of total enrollments) of Grenada in 2013?
Ensure brevity in your answer.  6.73. What is the difference between the Primary completion rate (% of total enrollments) in East Asia (all income levels) in 2010 and the Primary completion rate (% of total enrollments) in Sweden in 2013?
Give a very brief answer. 2.24. What is the difference between the Primary completion rate (% of total enrollments) of Dominica in 2010 and the Primary completion rate (% of total enrollments) of Grenada in 2013?
Provide a short and direct response. -13.74. What is the difference between the Primary completion rate (% of total enrollments) in Dominica in 2010 and the Primary completion rate (% of total enrollments) in Sweden in 2013?
Make the answer very short. -18.22. What is the difference between the Primary completion rate (% of total enrollments) in Grenada in 2010 and the Primary completion rate (% of total enrollments) in Sweden in 2013?
Provide a short and direct response. 17.41. What is the average Primary completion rate (% of total enrollments) of East Asia (all income levels) per year?
Provide a short and direct response. 99.29. What is the average Primary completion rate (% of total enrollments) of Dominica per year?
Keep it short and to the point. 94.22. What is the average Primary completion rate (% of total enrollments) of Grenada per year?
Make the answer very short. 107.1. What is the average Primary completion rate (% of total enrollments) in Sweden per year?
Your response must be concise. 98.87. In the year 2002, what is the difference between the Primary completion rate (% of total enrollments) in East Asia (all income levels) and Primary completion rate (% of total enrollments) in Dominica?
Provide a succinct answer. -10.29. In the year 2002, what is the difference between the Primary completion rate (% of total enrollments) in East Asia (all income levels) and Primary completion rate (% of total enrollments) in Grenada?
Your answer should be compact. -2.34. In the year 2002, what is the difference between the Primary completion rate (% of total enrollments) of East Asia (all income levels) and Primary completion rate (% of total enrollments) of Sweden?
Your answer should be very brief. -10.3. In the year 2002, what is the difference between the Primary completion rate (% of total enrollments) in Dominica and Primary completion rate (% of total enrollments) in Grenada?
Offer a very short reply. 7.94. In the year 2002, what is the difference between the Primary completion rate (% of total enrollments) of Dominica and Primary completion rate (% of total enrollments) of Sweden?
Provide a succinct answer. -0.02. In the year 2002, what is the difference between the Primary completion rate (% of total enrollments) in Grenada and Primary completion rate (% of total enrollments) in Sweden?
Provide a succinct answer. -7.96. In the year 2003, what is the difference between the Primary completion rate (% of total enrollments) in East Asia (all income levels) and Primary completion rate (% of total enrollments) in Dominica?
Make the answer very short. -8.38. In the year 2003, what is the difference between the Primary completion rate (% of total enrollments) of East Asia (all income levels) and Primary completion rate (% of total enrollments) of Grenada?
Provide a short and direct response. -7.45. In the year 2003, what is the difference between the Primary completion rate (% of total enrollments) in East Asia (all income levels) and Primary completion rate (% of total enrollments) in Sweden?
Your answer should be very brief. -13.12. In the year 2003, what is the difference between the Primary completion rate (% of total enrollments) in Dominica and Primary completion rate (% of total enrollments) in Grenada?
Provide a short and direct response. 0.93. In the year 2003, what is the difference between the Primary completion rate (% of total enrollments) in Dominica and Primary completion rate (% of total enrollments) in Sweden?
Provide a short and direct response. -4.74. In the year 2003, what is the difference between the Primary completion rate (% of total enrollments) of Grenada and Primary completion rate (% of total enrollments) of Sweden?
Your response must be concise. -5.67. In the year 2005, what is the difference between the Primary completion rate (% of total enrollments) in East Asia (all income levels) and Primary completion rate (% of total enrollments) in Dominica?
Your answer should be very brief. -4.03. In the year 2005, what is the difference between the Primary completion rate (% of total enrollments) in East Asia (all income levels) and Primary completion rate (% of total enrollments) in Grenada?
Your response must be concise. -8.86. In the year 2005, what is the difference between the Primary completion rate (% of total enrollments) of East Asia (all income levels) and Primary completion rate (% of total enrollments) of Sweden?
Your response must be concise. -6.22. In the year 2005, what is the difference between the Primary completion rate (% of total enrollments) in Dominica and Primary completion rate (% of total enrollments) in Grenada?
Give a very brief answer. -4.83. In the year 2005, what is the difference between the Primary completion rate (% of total enrollments) in Dominica and Primary completion rate (% of total enrollments) in Sweden?
Your answer should be compact. -2.19. In the year 2005, what is the difference between the Primary completion rate (% of total enrollments) of Grenada and Primary completion rate (% of total enrollments) of Sweden?
Offer a very short reply. 2.65. In the year 2007, what is the difference between the Primary completion rate (% of total enrollments) of East Asia (all income levels) and Primary completion rate (% of total enrollments) of Dominica?
Provide a succinct answer. 7.59. In the year 2007, what is the difference between the Primary completion rate (% of total enrollments) in East Asia (all income levels) and Primary completion rate (% of total enrollments) in Grenada?
Keep it short and to the point. 1.99. In the year 2007, what is the difference between the Primary completion rate (% of total enrollments) in East Asia (all income levels) and Primary completion rate (% of total enrollments) in Sweden?
Your answer should be compact. 4.23. In the year 2007, what is the difference between the Primary completion rate (% of total enrollments) of Dominica and Primary completion rate (% of total enrollments) of Grenada?
Ensure brevity in your answer.  -5.6. In the year 2007, what is the difference between the Primary completion rate (% of total enrollments) in Dominica and Primary completion rate (% of total enrollments) in Sweden?
Offer a terse response. -3.36. In the year 2007, what is the difference between the Primary completion rate (% of total enrollments) of Grenada and Primary completion rate (% of total enrollments) of Sweden?
Ensure brevity in your answer.  2.24. In the year 2008, what is the difference between the Primary completion rate (% of total enrollments) in East Asia (all income levels) and Primary completion rate (% of total enrollments) in Dominica?
Provide a succinct answer. 14.94. In the year 2008, what is the difference between the Primary completion rate (% of total enrollments) of East Asia (all income levels) and Primary completion rate (% of total enrollments) of Grenada?
Ensure brevity in your answer.  -13.2. In the year 2008, what is the difference between the Primary completion rate (% of total enrollments) of East Asia (all income levels) and Primary completion rate (% of total enrollments) of Sweden?
Offer a terse response. 7.09. In the year 2008, what is the difference between the Primary completion rate (% of total enrollments) of Dominica and Primary completion rate (% of total enrollments) of Grenada?
Offer a terse response. -28.14. In the year 2008, what is the difference between the Primary completion rate (% of total enrollments) in Dominica and Primary completion rate (% of total enrollments) in Sweden?
Keep it short and to the point. -7.85. In the year 2008, what is the difference between the Primary completion rate (% of total enrollments) of Grenada and Primary completion rate (% of total enrollments) of Sweden?
Offer a very short reply. 20.29. In the year 2009, what is the difference between the Primary completion rate (% of total enrollments) in East Asia (all income levels) and Primary completion rate (% of total enrollments) in Dominica?
Offer a very short reply. 18.17. In the year 2009, what is the difference between the Primary completion rate (% of total enrollments) of East Asia (all income levels) and Primary completion rate (% of total enrollments) of Grenada?
Make the answer very short. -24.71. In the year 2009, what is the difference between the Primary completion rate (% of total enrollments) in East Asia (all income levels) and Primary completion rate (% of total enrollments) in Sweden?
Your answer should be very brief. 11.46. In the year 2009, what is the difference between the Primary completion rate (% of total enrollments) of Dominica and Primary completion rate (% of total enrollments) of Grenada?
Your answer should be compact. -42.87. In the year 2009, what is the difference between the Primary completion rate (% of total enrollments) in Dominica and Primary completion rate (% of total enrollments) in Sweden?
Keep it short and to the point. -6.7. In the year 2009, what is the difference between the Primary completion rate (% of total enrollments) of Grenada and Primary completion rate (% of total enrollments) of Sweden?
Keep it short and to the point. 36.17. In the year 2010, what is the difference between the Primary completion rate (% of total enrollments) of East Asia (all income levels) and Primary completion rate (% of total enrollments) of Dominica?
Provide a short and direct response. 20.47. In the year 2010, what is the difference between the Primary completion rate (% of total enrollments) in East Asia (all income levels) and Primary completion rate (% of total enrollments) in Grenada?
Make the answer very short. -15.16. In the year 2010, what is the difference between the Primary completion rate (% of total enrollments) in East Asia (all income levels) and Primary completion rate (% of total enrollments) in Sweden?
Your response must be concise. 7.43. In the year 2010, what is the difference between the Primary completion rate (% of total enrollments) of Dominica and Primary completion rate (% of total enrollments) of Grenada?
Give a very brief answer. -35.63. In the year 2010, what is the difference between the Primary completion rate (% of total enrollments) in Dominica and Primary completion rate (% of total enrollments) in Sweden?
Keep it short and to the point. -13.04. In the year 2010, what is the difference between the Primary completion rate (% of total enrollments) of Grenada and Primary completion rate (% of total enrollments) of Sweden?
Provide a succinct answer. 22.59. In the year 2013, what is the difference between the Primary completion rate (% of total enrollments) of East Asia (all income levels) and Primary completion rate (% of total enrollments) of Dominica?
Provide a short and direct response. 2.13. In the year 2013, what is the difference between the Primary completion rate (% of total enrollments) in East Asia (all income levels) and Primary completion rate (% of total enrollments) in Grenada?
Ensure brevity in your answer.  7.28. In the year 2013, what is the difference between the Primary completion rate (% of total enrollments) of East Asia (all income levels) and Primary completion rate (% of total enrollments) of Sweden?
Your answer should be compact. 2.8. In the year 2013, what is the difference between the Primary completion rate (% of total enrollments) in Dominica and Primary completion rate (% of total enrollments) in Grenada?
Give a very brief answer. 5.16. In the year 2013, what is the difference between the Primary completion rate (% of total enrollments) in Dominica and Primary completion rate (% of total enrollments) in Sweden?
Provide a short and direct response. 0.67. In the year 2013, what is the difference between the Primary completion rate (% of total enrollments) in Grenada and Primary completion rate (% of total enrollments) in Sweden?
Give a very brief answer. -4.48. What is the ratio of the Primary completion rate (% of total enrollments) of East Asia (all income levels) in 2002 to that in 2003?
Keep it short and to the point. 0.99. What is the ratio of the Primary completion rate (% of total enrollments) of Dominica in 2002 to that in 2003?
Ensure brevity in your answer.  1.01. What is the ratio of the Primary completion rate (% of total enrollments) of Grenada in 2002 to that in 2003?
Keep it short and to the point. 0.94. What is the ratio of the Primary completion rate (% of total enrollments) in Sweden in 2002 to that in 2003?
Offer a terse response. 0.97. What is the ratio of the Primary completion rate (% of total enrollments) in East Asia (all income levels) in 2002 to that in 2005?
Your answer should be very brief. 0.98. What is the ratio of the Primary completion rate (% of total enrollments) of Dominica in 2002 to that in 2005?
Give a very brief answer. 1.04. What is the ratio of the Primary completion rate (% of total enrollments) in Grenada in 2002 to that in 2005?
Your answer should be very brief. 0.92. What is the ratio of the Primary completion rate (% of total enrollments) of Sweden in 2002 to that in 2005?
Your answer should be very brief. 1.02. What is the ratio of the Primary completion rate (% of total enrollments) in Dominica in 2002 to that in 2007?
Your answer should be very brief. 1.12. What is the ratio of the Primary completion rate (% of total enrollments) in Grenada in 2002 to that in 2007?
Offer a very short reply. 0.98. What is the ratio of the Primary completion rate (% of total enrollments) of Sweden in 2002 to that in 2007?
Your response must be concise. 1.08. What is the ratio of the Primary completion rate (% of total enrollments) in East Asia (all income levels) in 2002 to that in 2008?
Provide a short and direct response. 0.91. What is the ratio of the Primary completion rate (% of total enrollments) in Dominica in 2002 to that in 2008?
Give a very brief answer. 1.18. What is the ratio of the Primary completion rate (% of total enrollments) in Grenada in 2002 to that in 2008?
Provide a succinct answer. 0.83. What is the ratio of the Primary completion rate (% of total enrollments) in Sweden in 2002 to that in 2008?
Make the answer very short. 1.09. What is the ratio of the Primary completion rate (% of total enrollments) in East Asia (all income levels) in 2002 to that in 2009?
Your response must be concise. 0.89. What is the ratio of the Primary completion rate (% of total enrollments) of Dominica in 2002 to that in 2009?
Offer a terse response. 1.19. What is the ratio of the Primary completion rate (% of total enrollments) in Grenada in 2002 to that in 2009?
Your answer should be compact. 0.74. What is the ratio of the Primary completion rate (% of total enrollments) in Sweden in 2002 to that in 2009?
Ensure brevity in your answer.  1.11. What is the ratio of the Primary completion rate (% of total enrollments) of East Asia (all income levels) in 2002 to that in 2010?
Provide a short and direct response. 0.89. What is the ratio of the Primary completion rate (% of total enrollments) of Dominica in 2002 to that in 2010?
Ensure brevity in your answer.  1.22. What is the ratio of the Primary completion rate (% of total enrollments) of Grenada in 2002 to that in 2010?
Provide a short and direct response. 0.79. What is the ratio of the Primary completion rate (% of total enrollments) in Sweden in 2002 to that in 2010?
Offer a terse response. 1.06. What is the ratio of the Primary completion rate (% of total enrollments) of East Asia (all income levels) in 2002 to that in 2013?
Provide a succinct answer. 0.88. What is the ratio of the Primary completion rate (% of total enrollments) in Grenada in 2002 to that in 2013?
Give a very brief answer. 0.97. What is the ratio of the Primary completion rate (% of total enrollments) in Sweden in 2002 to that in 2013?
Ensure brevity in your answer.  1.01. What is the ratio of the Primary completion rate (% of total enrollments) of Dominica in 2003 to that in 2005?
Give a very brief answer. 1.03. What is the ratio of the Primary completion rate (% of total enrollments) of Grenada in 2003 to that in 2005?
Give a very brief answer. 0.98. What is the ratio of the Primary completion rate (% of total enrollments) in Sweden in 2003 to that in 2005?
Keep it short and to the point. 1.06. What is the ratio of the Primary completion rate (% of total enrollments) in East Asia (all income levels) in 2003 to that in 2007?
Provide a succinct answer. 0.94. What is the ratio of the Primary completion rate (% of total enrollments) of Dominica in 2003 to that in 2007?
Give a very brief answer. 1.11. What is the ratio of the Primary completion rate (% of total enrollments) in Sweden in 2003 to that in 2007?
Your answer should be compact. 1.12. What is the ratio of the Primary completion rate (% of total enrollments) of East Asia (all income levels) in 2003 to that in 2008?
Provide a succinct answer. 0.92. What is the ratio of the Primary completion rate (% of total enrollments) in Dominica in 2003 to that in 2008?
Offer a terse response. 1.17. What is the ratio of the Primary completion rate (% of total enrollments) in Grenada in 2003 to that in 2008?
Offer a terse response. 0.88. What is the ratio of the Primary completion rate (% of total enrollments) of Sweden in 2003 to that in 2008?
Your answer should be compact. 1.13. What is the ratio of the Primary completion rate (% of total enrollments) in East Asia (all income levels) in 2003 to that in 2009?
Your answer should be very brief. 0.9. What is the ratio of the Primary completion rate (% of total enrollments) of Dominica in 2003 to that in 2009?
Give a very brief answer. 1.18. What is the ratio of the Primary completion rate (% of total enrollments) of Grenada in 2003 to that in 2009?
Your answer should be compact. 0.78. What is the ratio of the Primary completion rate (% of total enrollments) of Sweden in 2003 to that in 2009?
Your answer should be very brief. 1.15. What is the ratio of the Primary completion rate (% of total enrollments) in East Asia (all income levels) in 2003 to that in 2010?
Offer a very short reply. 0.89. What is the ratio of the Primary completion rate (% of total enrollments) of Dominica in 2003 to that in 2010?
Your answer should be compact. 1.21. What is the ratio of the Primary completion rate (% of total enrollments) in Grenada in 2003 to that in 2010?
Make the answer very short. 0.84. What is the ratio of the Primary completion rate (% of total enrollments) in Sweden in 2003 to that in 2010?
Provide a succinct answer. 1.1. What is the ratio of the Primary completion rate (% of total enrollments) in East Asia (all income levels) in 2003 to that in 2013?
Offer a terse response. 0.89. What is the ratio of the Primary completion rate (% of total enrollments) of Grenada in 2003 to that in 2013?
Provide a short and direct response. 1.03. What is the ratio of the Primary completion rate (% of total enrollments) of Sweden in 2003 to that in 2013?
Offer a very short reply. 1.04. What is the ratio of the Primary completion rate (% of total enrollments) in Dominica in 2005 to that in 2007?
Your response must be concise. 1.07. What is the ratio of the Primary completion rate (% of total enrollments) of Grenada in 2005 to that in 2007?
Your response must be concise. 1.06. What is the ratio of the Primary completion rate (% of total enrollments) of Sweden in 2005 to that in 2007?
Ensure brevity in your answer.  1.06. What is the ratio of the Primary completion rate (% of total enrollments) in East Asia (all income levels) in 2005 to that in 2008?
Offer a very short reply. 0.93. What is the ratio of the Primary completion rate (% of total enrollments) of Dominica in 2005 to that in 2008?
Your response must be concise. 1.13. What is the ratio of the Primary completion rate (% of total enrollments) of Grenada in 2005 to that in 2008?
Your answer should be compact. 0.9. What is the ratio of the Primary completion rate (% of total enrollments) in Sweden in 2005 to that in 2008?
Keep it short and to the point. 1.06. What is the ratio of the Primary completion rate (% of total enrollments) in East Asia (all income levels) in 2005 to that in 2009?
Give a very brief answer. 0.91. What is the ratio of the Primary completion rate (% of total enrollments) of Dominica in 2005 to that in 2009?
Make the answer very short. 1.14. What is the ratio of the Primary completion rate (% of total enrollments) in Grenada in 2005 to that in 2009?
Ensure brevity in your answer.  0.8. What is the ratio of the Primary completion rate (% of total enrollments) in Sweden in 2005 to that in 2009?
Provide a succinct answer. 1.08. What is the ratio of the Primary completion rate (% of total enrollments) of East Asia (all income levels) in 2005 to that in 2010?
Keep it short and to the point. 0.9. What is the ratio of the Primary completion rate (% of total enrollments) of Dominica in 2005 to that in 2010?
Provide a succinct answer. 1.17. What is the ratio of the Primary completion rate (% of total enrollments) of Grenada in 2005 to that in 2010?
Make the answer very short. 0.86. What is the ratio of the Primary completion rate (% of total enrollments) in Sweden in 2005 to that in 2010?
Your answer should be compact. 1.04. What is the ratio of the Primary completion rate (% of total enrollments) of East Asia (all income levels) in 2005 to that in 2013?
Your response must be concise. 0.9. What is the ratio of the Primary completion rate (% of total enrollments) in Dominica in 2005 to that in 2013?
Provide a succinct answer. 0.96. What is the ratio of the Primary completion rate (% of total enrollments) of Grenada in 2005 to that in 2013?
Your response must be concise. 1.06. What is the ratio of the Primary completion rate (% of total enrollments) in East Asia (all income levels) in 2007 to that in 2008?
Ensure brevity in your answer.  0.97. What is the ratio of the Primary completion rate (% of total enrollments) of Dominica in 2007 to that in 2008?
Keep it short and to the point. 1.05. What is the ratio of the Primary completion rate (% of total enrollments) in Grenada in 2007 to that in 2008?
Your answer should be very brief. 0.85. What is the ratio of the Primary completion rate (% of total enrollments) in Sweden in 2007 to that in 2008?
Offer a terse response. 1. What is the ratio of the Primary completion rate (% of total enrollments) of East Asia (all income levels) in 2007 to that in 2009?
Your answer should be compact. 0.95. What is the ratio of the Primary completion rate (% of total enrollments) of Dominica in 2007 to that in 2009?
Make the answer very short. 1.06. What is the ratio of the Primary completion rate (% of total enrollments) of Grenada in 2007 to that in 2009?
Provide a succinct answer. 0.75. What is the ratio of the Primary completion rate (% of total enrollments) in Sweden in 2007 to that in 2009?
Give a very brief answer. 1.02. What is the ratio of the Primary completion rate (% of total enrollments) of East Asia (all income levels) in 2007 to that in 2010?
Ensure brevity in your answer.  0.95. What is the ratio of the Primary completion rate (% of total enrollments) of Dominica in 2007 to that in 2010?
Offer a terse response. 1.09. What is the ratio of the Primary completion rate (% of total enrollments) in Grenada in 2007 to that in 2010?
Keep it short and to the point. 0.81. What is the ratio of the Primary completion rate (% of total enrollments) of Sweden in 2007 to that in 2010?
Your response must be concise. 0.98. What is the ratio of the Primary completion rate (% of total enrollments) in East Asia (all income levels) in 2007 to that in 2013?
Provide a succinct answer. 0.94. What is the ratio of the Primary completion rate (% of total enrollments) in Dominica in 2007 to that in 2013?
Provide a succinct answer. 0.89. What is the ratio of the Primary completion rate (% of total enrollments) in Sweden in 2007 to that in 2013?
Offer a terse response. 0.93. What is the ratio of the Primary completion rate (% of total enrollments) of East Asia (all income levels) in 2008 to that in 2009?
Provide a succinct answer. 0.98. What is the ratio of the Primary completion rate (% of total enrollments) in Dominica in 2008 to that in 2009?
Provide a short and direct response. 1.01. What is the ratio of the Primary completion rate (% of total enrollments) of Grenada in 2008 to that in 2009?
Your answer should be compact. 0.89. What is the ratio of the Primary completion rate (% of total enrollments) of East Asia (all income levels) in 2008 to that in 2010?
Offer a very short reply. 0.97. What is the ratio of the Primary completion rate (% of total enrollments) of Dominica in 2008 to that in 2010?
Provide a short and direct response. 1.03. What is the ratio of the Primary completion rate (% of total enrollments) in Grenada in 2008 to that in 2010?
Your answer should be compact. 0.96. What is the ratio of the Primary completion rate (% of total enrollments) in Sweden in 2008 to that in 2010?
Offer a very short reply. 0.98. What is the ratio of the Primary completion rate (% of total enrollments) of East Asia (all income levels) in 2008 to that in 2013?
Provide a short and direct response. 0.97. What is the ratio of the Primary completion rate (% of total enrollments) in Dominica in 2008 to that in 2013?
Keep it short and to the point. 0.84. What is the ratio of the Primary completion rate (% of total enrollments) of Grenada in 2008 to that in 2013?
Offer a very short reply. 1.18. What is the ratio of the Primary completion rate (% of total enrollments) in Sweden in 2008 to that in 2013?
Offer a very short reply. 0.93. What is the ratio of the Primary completion rate (% of total enrollments) in Dominica in 2009 to that in 2010?
Make the answer very short. 1.02. What is the ratio of the Primary completion rate (% of total enrollments) in Grenada in 2009 to that in 2010?
Offer a very short reply. 1.08. What is the ratio of the Primary completion rate (% of total enrollments) of Sweden in 2009 to that in 2010?
Ensure brevity in your answer.  0.96. What is the ratio of the Primary completion rate (% of total enrollments) of East Asia (all income levels) in 2009 to that in 2013?
Provide a succinct answer. 0.99. What is the ratio of the Primary completion rate (% of total enrollments) in Dominica in 2009 to that in 2013?
Give a very brief answer. 0.84. What is the ratio of the Primary completion rate (% of total enrollments) in Grenada in 2009 to that in 2013?
Provide a succinct answer. 1.32. What is the ratio of the Primary completion rate (% of total enrollments) of Sweden in 2009 to that in 2013?
Keep it short and to the point. 0.91. What is the ratio of the Primary completion rate (% of total enrollments) of Dominica in 2010 to that in 2013?
Ensure brevity in your answer.  0.82. What is the ratio of the Primary completion rate (% of total enrollments) in Grenada in 2010 to that in 2013?
Ensure brevity in your answer.  1.22. What is the ratio of the Primary completion rate (% of total enrollments) in Sweden in 2010 to that in 2013?
Provide a succinct answer. 0.95. What is the difference between the highest and the second highest Primary completion rate (% of total enrollments) in East Asia (all income levels)?
Provide a succinct answer. 0.55. What is the difference between the highest and the second highest Primary completion rate (% of total enrollments) in Dominica?
Offer a very short reply. 0.08. What is the difference between the highest and the second highest Primary completion rate (% of total enrollments) of Grenada?
Ensure brevity in your answer.  9.32. What is the difference between the highest and the second highest Primary completion rate (% of total enrollments) in Sweden?
Offer a very short reply. 3.71. What is the difference between the highest and the lowest Primary completion rate (% of total enrollments) of East Asia (all income levels)?
Provide a succinct answer. 12.49. What is the difference between the highest and the lowest Primary completion rate (% of total enrollments) of Dominica?
Offer a very short reply. 18.9. What is the difference between the highest and the lowest Primary completion rate (% of total enrollments) of Grenada?
Your answer should be very brief. 34.07. What is the difference between the highest and the lowest Primary completion rate (% of total enrollments) of Sweden?
Ensure brevity in your answer.  13.77. 